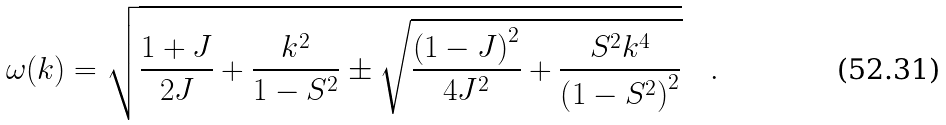Convert formula to latex. <formula><loc_0><loc_0><loc_500><loc_500>\omega ( k ) = \sqrt { \frac { 1 + J } { 2 J } + \frac { k ^ { 2 } } { 1 - S ^ { 2 } } \pm \sqrt { \frac { \left ( 1 - J \right ) ^ { 2 } } { 4 J ^ { 2 } } + \frac { S ^ { 2 } k ^ { 4 } } { \left ( 1 - S ^ { 2 } \right ) ^ { 2 } } } } \quad .</formula> 